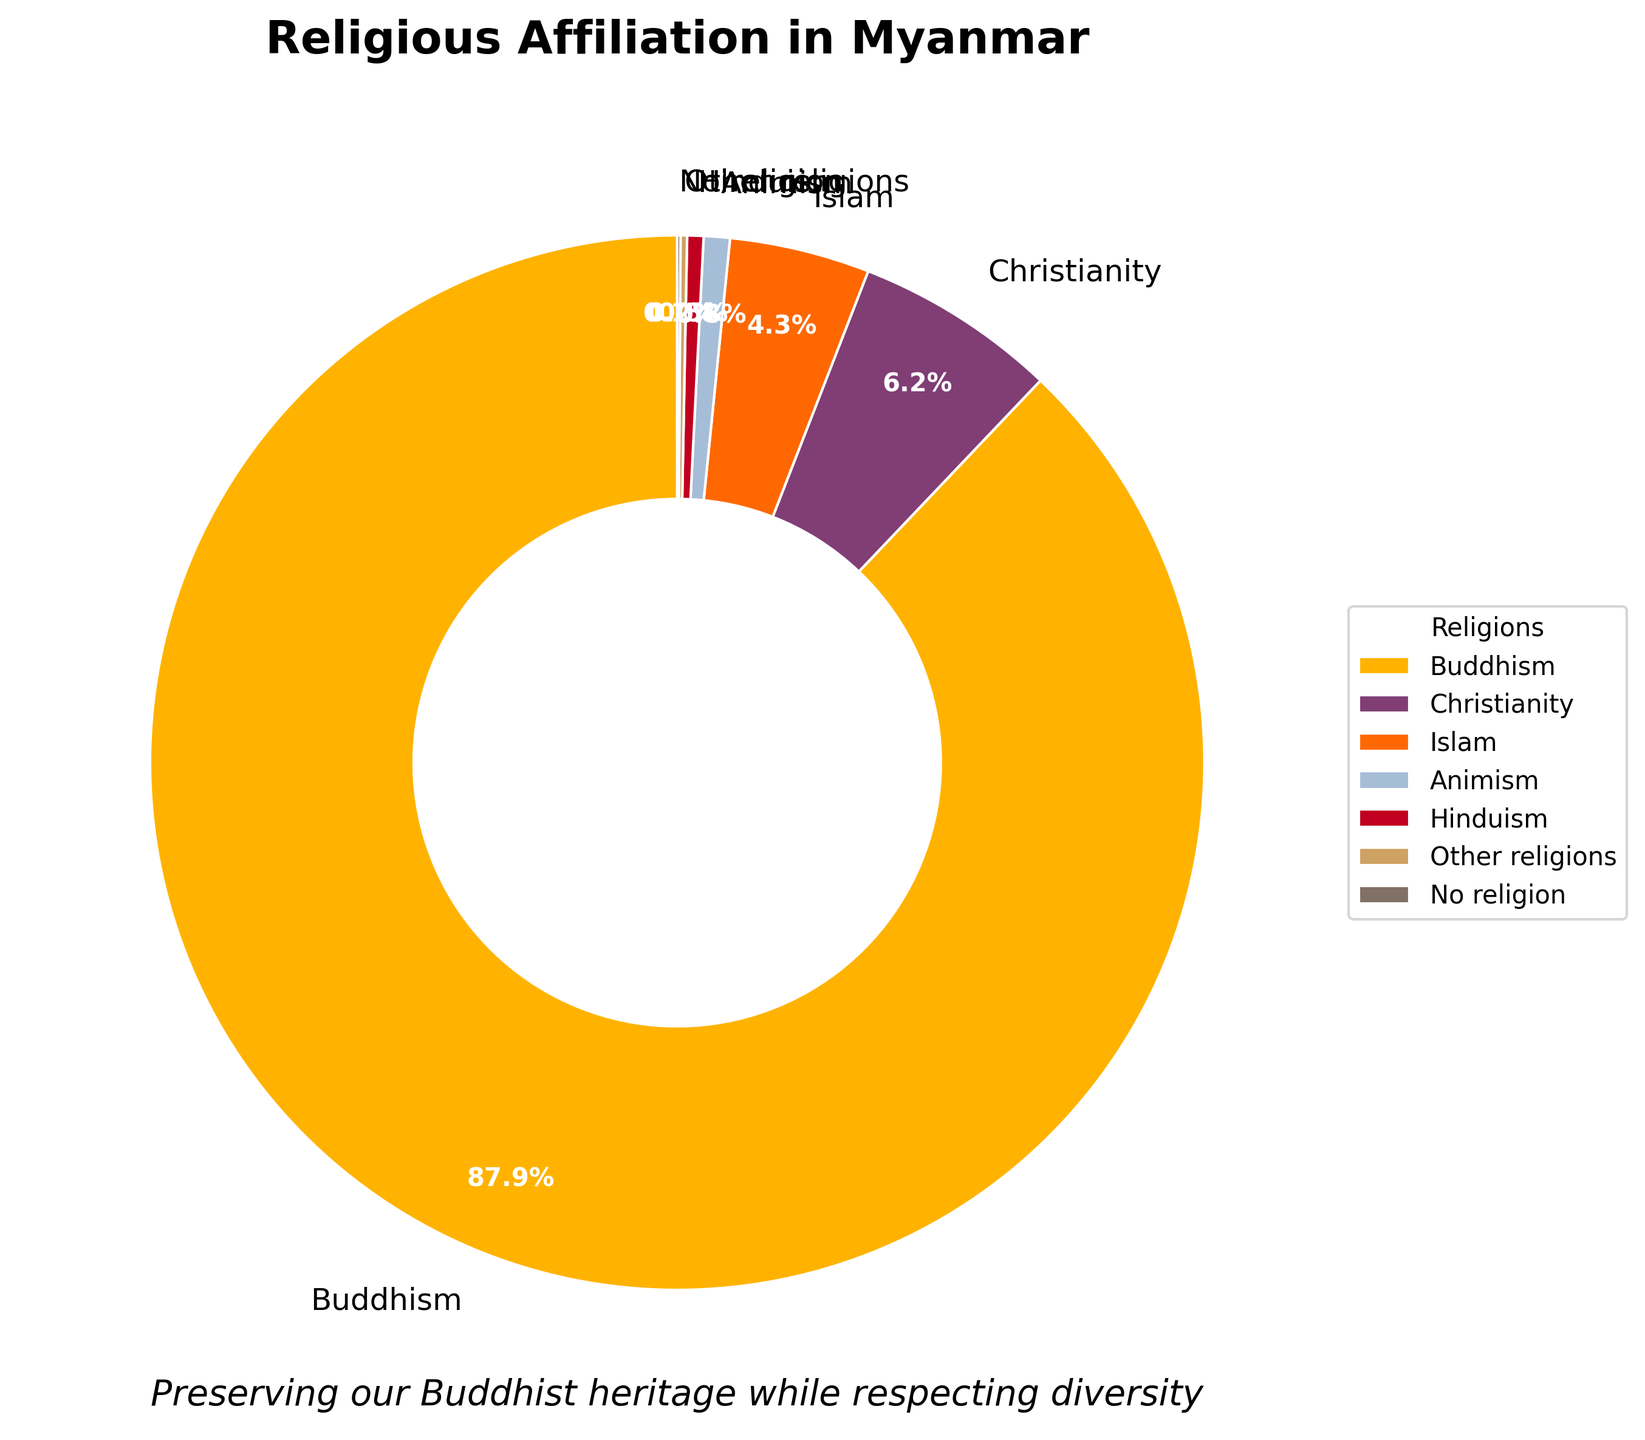Which religion has the highest percentage? The pie chart shows different religious affiliations in Myanmar, with Buddhism having the largest segment, filling most of the chart.
Answer: Buddhism What is the combined percentage of Christianity and Islam? Adding the percentages of Christianity (6.2%) and Islam (4.3%) by looking at their respective segments in the chart gives: 6.2 + 4.3 = 10.5%.
Answer: 10.5% Which religions have less than 1% of the population? The pie chart shows several religions with small segments, specifically Animism (0.8%), Hinduism (0.5%), Other religions (0.2%), and No religion (0.1%) all have percentages less than 1%.
Answer: Animism, Hinduism, Other religions, No religion How much larger is the Buddhist population compared to the Christian population? The chart shows Buddhism at 87.9% and Christianity at 6.2%. The difference is calculated as 87.9 - 6.2, which is 81.7%.
Answer: 81.7% What is the average percentage of all religions with less than 1% representation? Summing the percentages of Animism, Hinduism, Other religions, and No religion: 0.8 + 0.5 + 0.2 + 0.1 = 1.6%. Dividing by the number of these religions (4) gives: 1.6 / 4 = 0.4%.
Answer: 0.4% How does the percentage of people with No religion compare to the percentage of people practicing Hinduism? The chart shows No religion at 0.1% and Hinduism at 0.5%. By comparing these values, we see that Hinduism has a higher percentage.
Answer: Hinduism has a higher percentage Which segment has the smallest representation in the pie chart, and what is its color? No religion has the smallest segment with 0.1%, and in the pie chart, this segment is represented by the darkest color, likely dark grey or a similar shade.
Answer: No religion, dark grey How many times larger is the Buddhist population compared to the Islamic population? Buddhism is 87.9% and Islam is 4.3%. Dividing these gives: 87.9 / 4.3 ≈ 20.4. Thus, the Buddhist population is about 20.4 times larger than the Islamic population.
Answer: 20.4 times What percentage of the population is affiliated with neither Buddhism nor Christianity? Summing the percentages of all religions except Buddhism (87.9%) and Christianity (6.2%): 100 - 87.9 - 6.2 = 5.9%.
Answer: 5.9% Which religion is represented by a segment whose color appears closest to blue? According to the chart's colors, Animism appears to be represented by the segment closest to blue.
Answer: Animism 